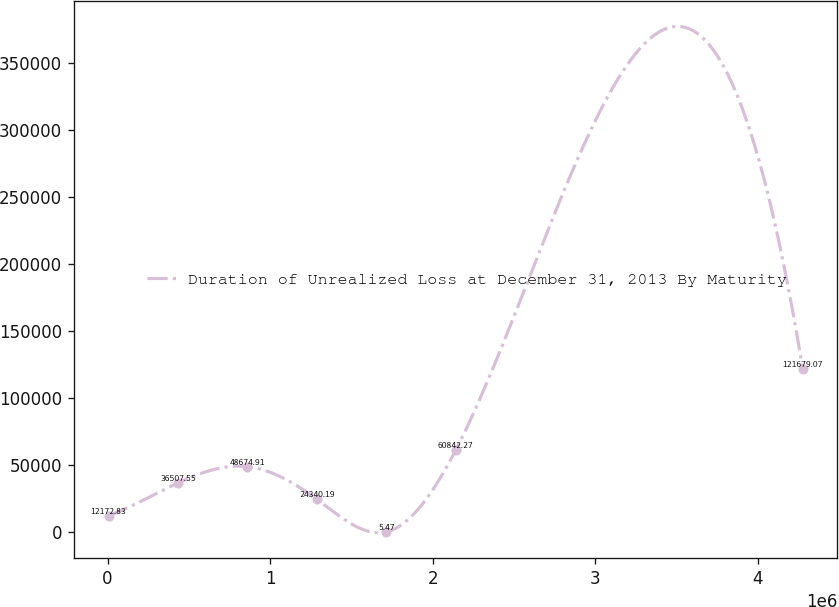Convert chart to OTSL. <chart><loc_0><loc_0><loc_500><loc_500><line_chart><ecel><fcel>Duration of Unrealized Loss at December 31, 2013 By Maturity<nl><fcel>6089.74<fcel>12172.8<nl><fcel>433115<fcel>36507.6<nl><fcel>860140<fcel>48674.9<nl><fcel>1.28717e+06<fcel>24340.2<nl><fcel>1.71419e+06<fcel>5.47<nl><fcel>2.14122e+06<fcel>60842.3<nl><fcel>4.27634e+06<fcel>121679<nl></chart> 